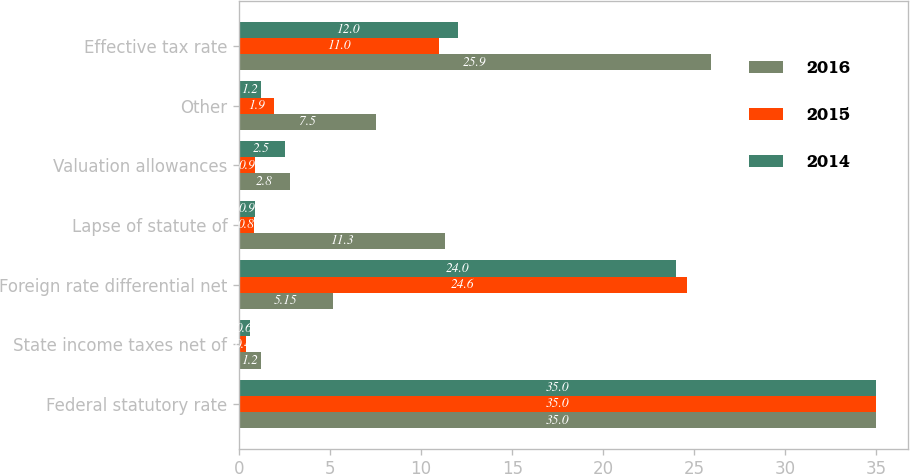Convert chart to OTSL. <chart><loc_0><loc_0><loc_500><loc_500><stacked_bar_chart><ecel><fcel>Federal statutory rate<fcel>State income taxes net of<fcel>Foreign rate differential net<fcel>Lapse of statute of<fcel>Valuation allowances<fcel>Other<fcel>Effective tax rate<nl><fcel>2016<fcel>35<fcel>1.2<fcel>5.15<fcel>11.3<fcel>2.8<fcel>7.5<fcel>25.9<nl><fcel>2015<fcel>35<fcel>0.4<fcel>24.6<fcel>0.8<fcel>0.9<fcel>1.9<fcel>11<nl><fcel>2014<fcel>35<fcel>0.6<fcel>24<fcel>0.9<fcel>2.5<fcel>1.2<fcel>12<nl></chart> 